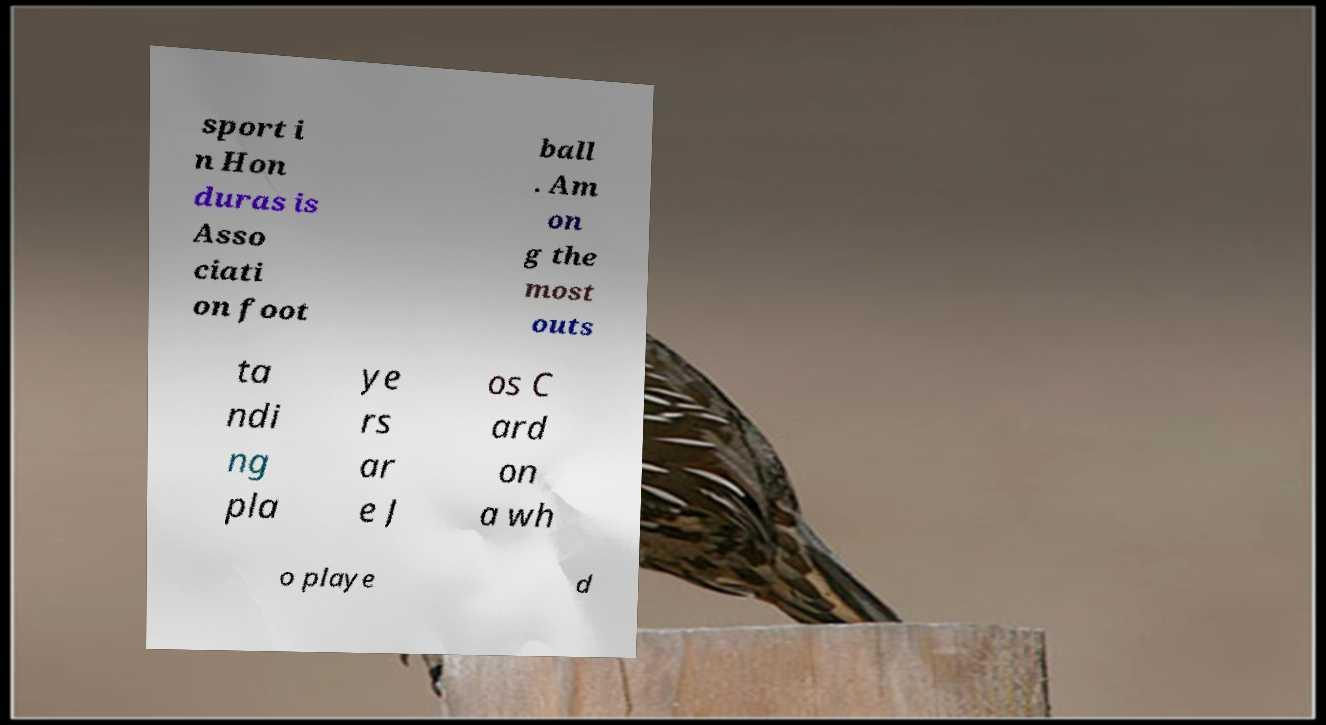Could you extract and type out the text from this image? sport i n Hon duras is Asso ciati on foot ball . Am on g the most outs ta ndi ng pla ye rs ar e J os C ard on a wh o playe d 